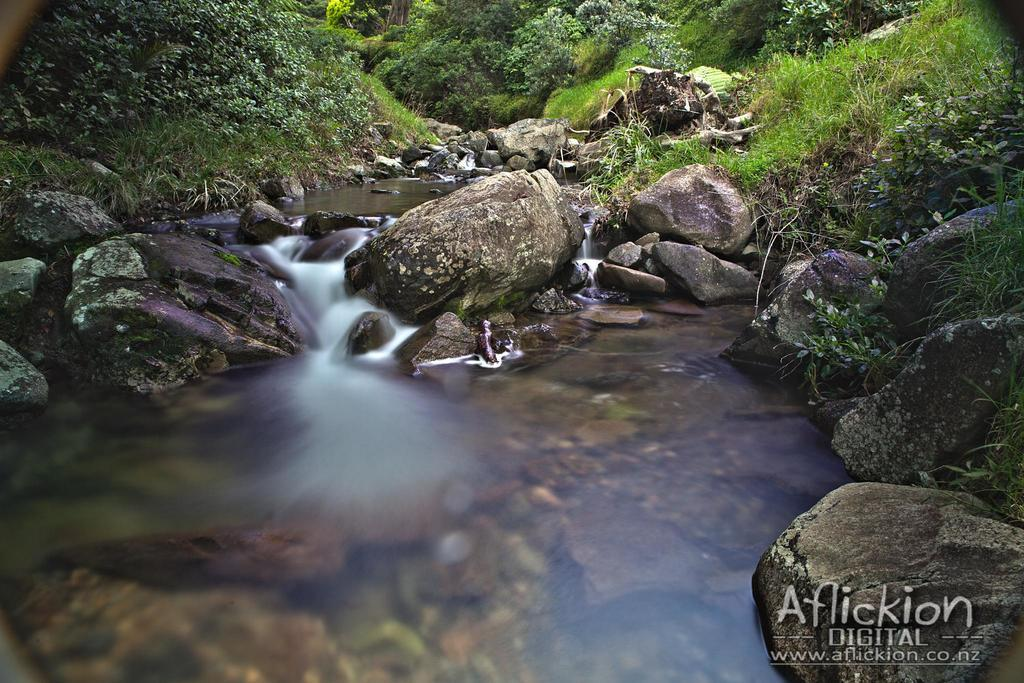What is the primary element visible in the image? There is water in the image. What other objects or features can be seen in the image? There are stones and green color plants in the image. Where can the cemetery be found in the image? There is no cemetery present in the image; it features water, stones, and green color plants. 